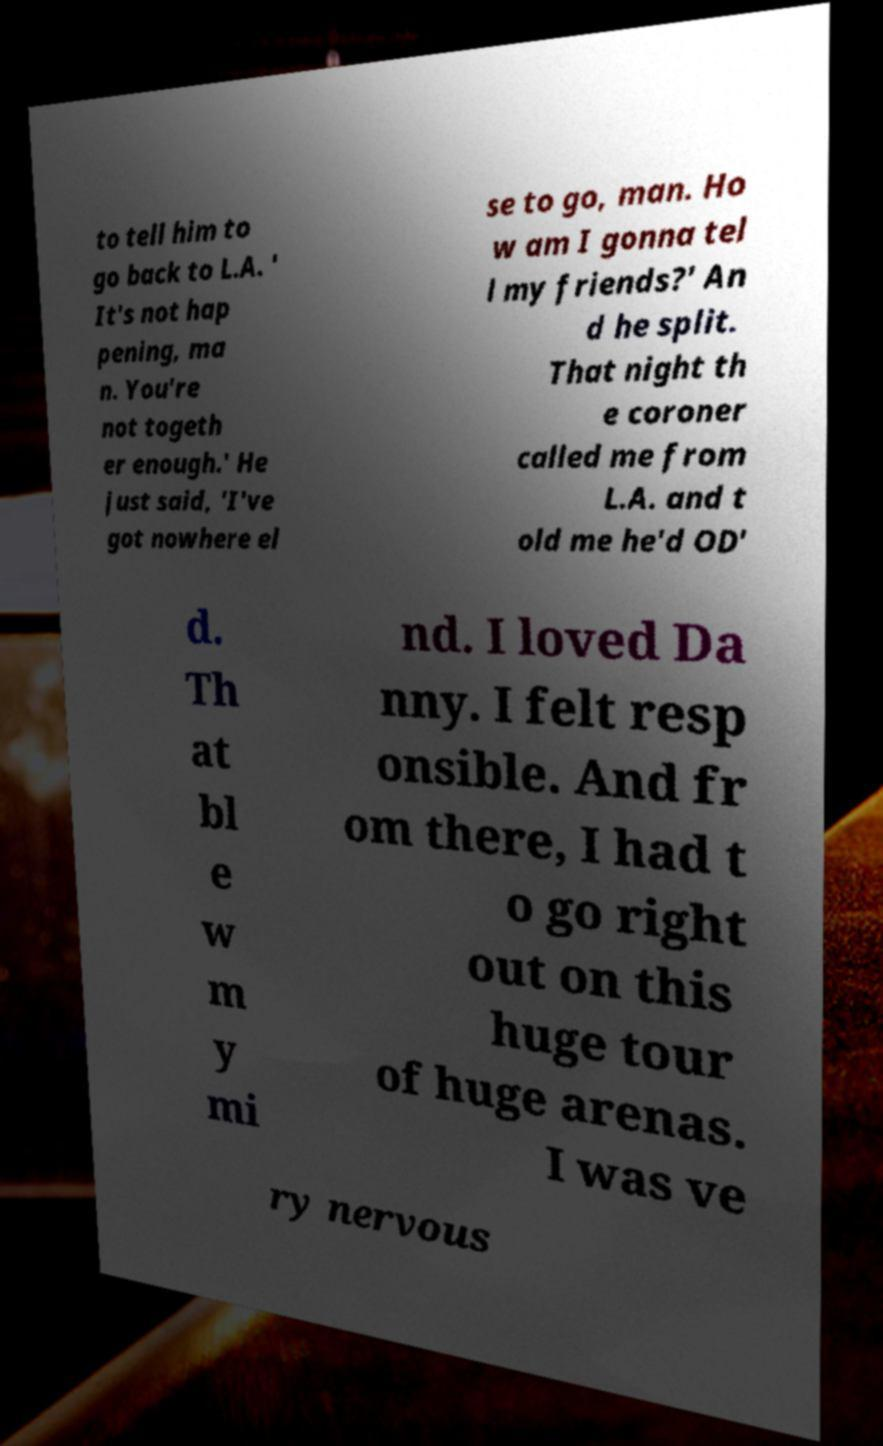There's text embedded in this image that I need extracted. Can you transcribe it verbatim? to tell him to go back to L.A. ' It's not hap pening, ma n. You're not togeth er enough.' He just said, 'I've got nowhere el se to go, man. Ho w am I gonna tel l my friends?' An d he split. That night th e coroner called me from L.A. and t old me he'd OD' d. Th at bl e w m y mi nd. I loved Da nny. I felt resp onsible. And fr om there, I had t o go right out on this huge tour of huge arenas. I was ve ry nervous 